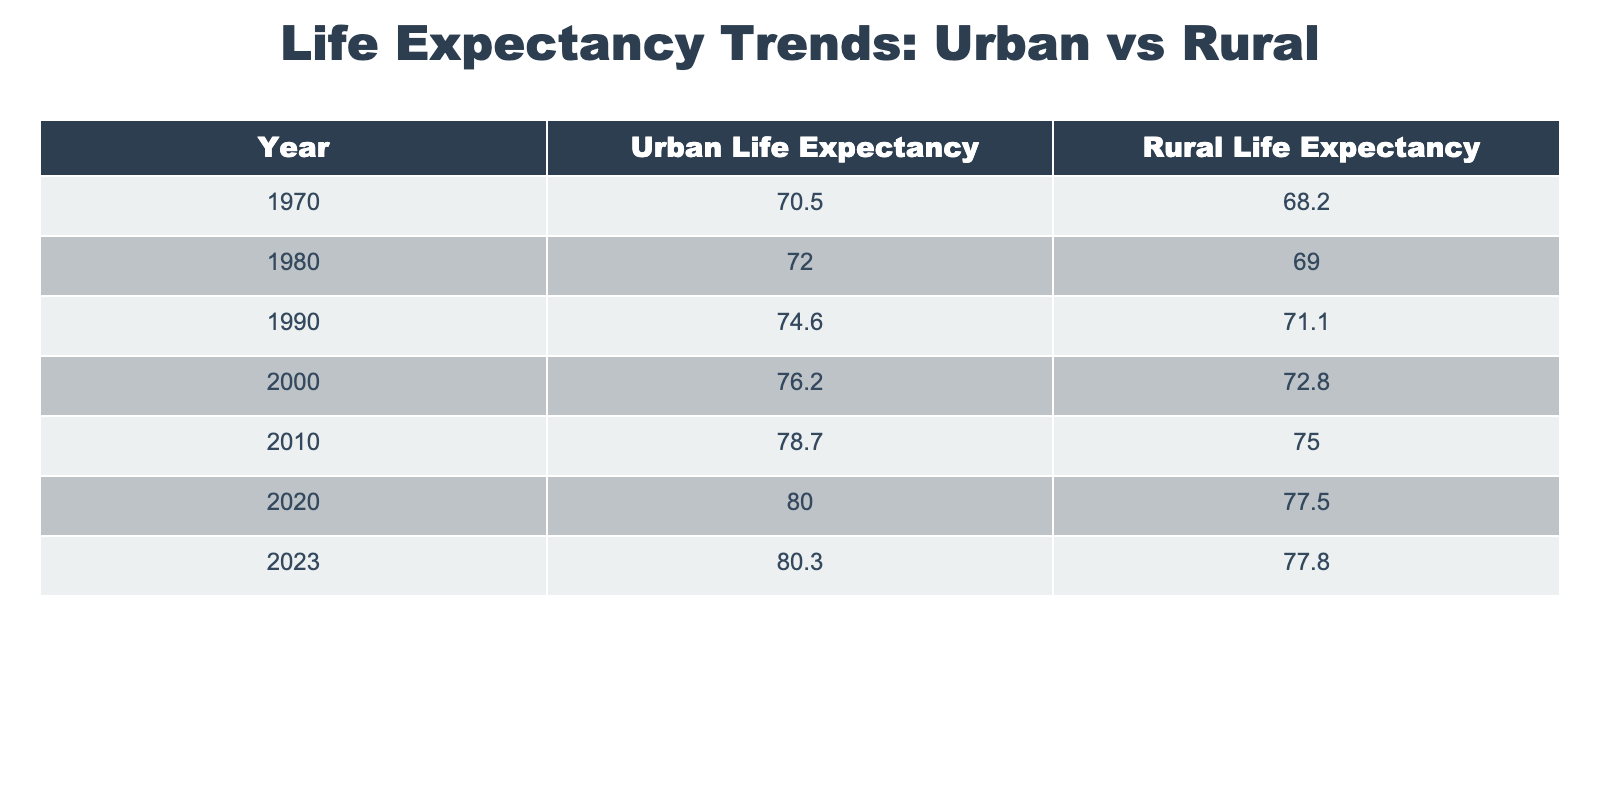What was the life expectancy in urban areas in 2000? According to the table, the urban life expectancy for the year 2000 is listed as 76.2.
Answer: 76.2 What was the life expectancy for rural areas in 1990? The table shows that the rural life expectancy in 1990 was 71.1.
Answer: 71.1 Has urban life expectancy generally increased over the last 50 years? By observing the data from each decade, urban life expectancy has consistently risen, from 70.5 in 1970 to 80.3 in 2023, indicating a general upward trend.
Answer: Yes What is the difference in life expectancy between urban and rural areas in 2010? For the year 2010, the urban life expectancy was 78.7 and the rural life expectancy was 75.0. The difference is calculated as 78.7 - 75.0, which equals 3.7.
Answer: 3.7 What was the average life expectancy for rural areas from 1970 to 2023? To calculate the average rural life expectancy, sum the values from the years provided (68.2 + 69.0 + 71.1 + 72.8 + 75.0 + 77.5 + 77.8) = 511.4, then divide by the number of years (7) to get an average of 511.4 / 7 = 73.1.
Answer: 73.1 Was the life expectancy in rural areas higher than in urban areas in 1970? In 1970, the urban life expectancy was 70.5 while the rural life expectancy was 68.2. Since 70.5 is greater than 68.2, the statement is false.
Answer: No Which year showed the smallest increase in urban life expectancy compared to the previous decade? Comparing the increases decade by decade: 1970-1980 (1.5), 1980-1990 (2.6), 1990-2000 (1.6), 2000-2010 (2.5), 2010-2020 (1.3), and 2020-2023 (0.3). The smallest increase was from 2020 to 2023, which is 0.3.
Answer: 2020-2023 What was the percentage increase in life expectancy for urban areas from 2000 to 2023? First, we calculate the absolute increase: 80.3 (2023) - 76.2 (2000) = 4.1. Next, the percentage increase is (4.1 / 76.2) * 100, which results in approximately 5.39%.
Answer: 5.39% 